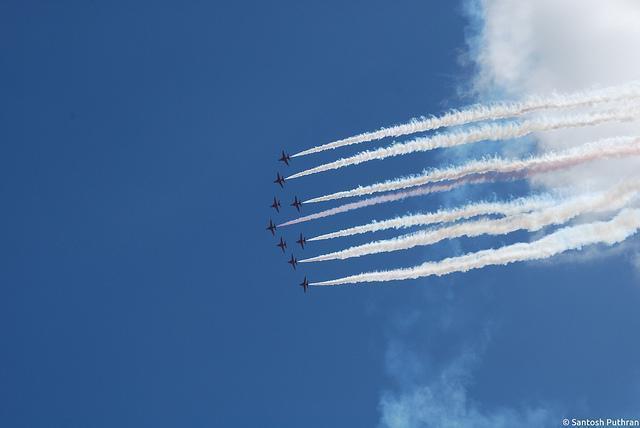What is the white trail behind the plane called?
Indicate the correct response by choosing from the four available options to answer the question.
Options: Banner, net, cloud, contrail. Contrail. 